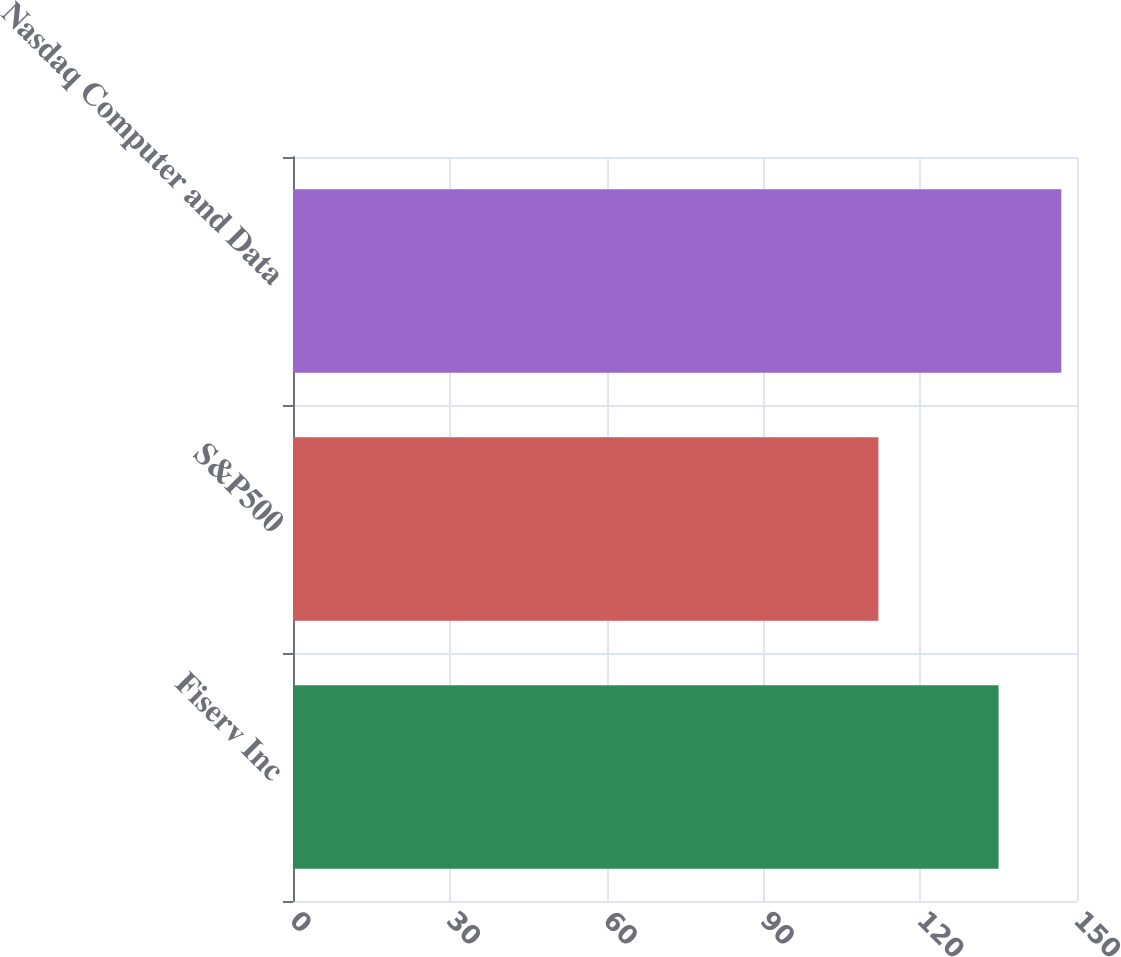<chart> <loc_0><loc_0><loc_500><loc_500><bar_chart><fcel>Fiserv Inc<fcel>S&P500<fcel>Nasdaq Computer and Data<nl><fcel>135<fcel>112<fcel>147<nl></chart> 